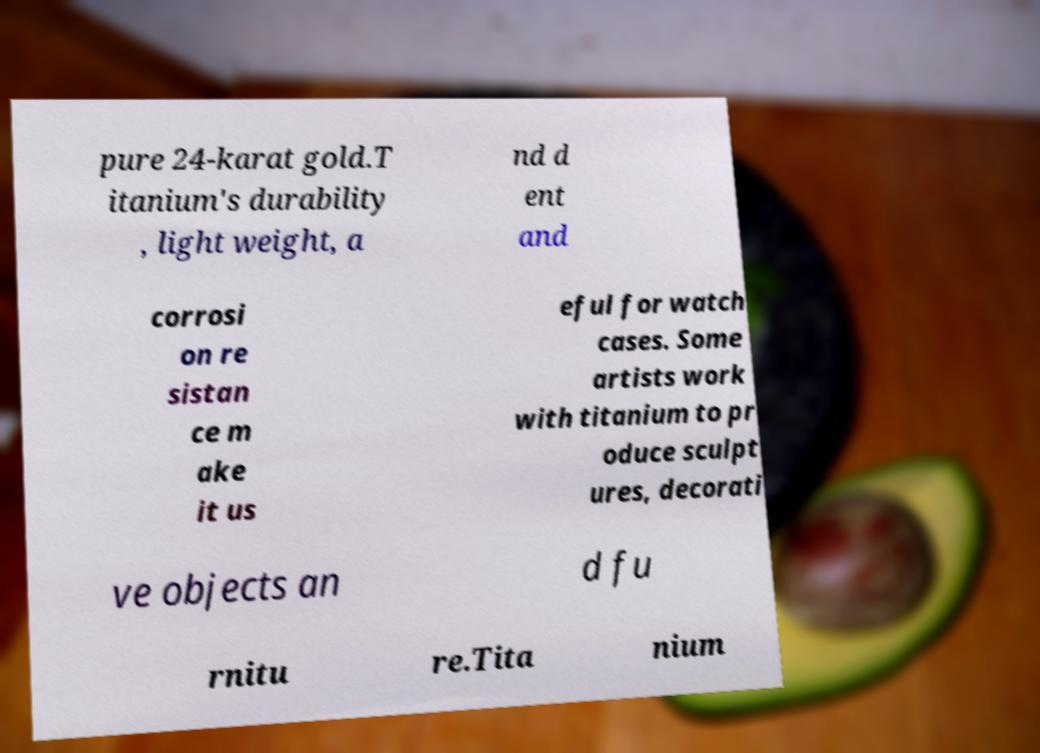What messages or text are displayed in this image? I need them in a readable, typed format. pure 24-karat gold.T itanium's durability , light weight, a nd d ent and corrosi on re sistan ce m ake it us eful for watch cases. Some artists work with titanium to pr oduce sculpt ures, decorati ve objects an d fu rnitu re.Tita nium 